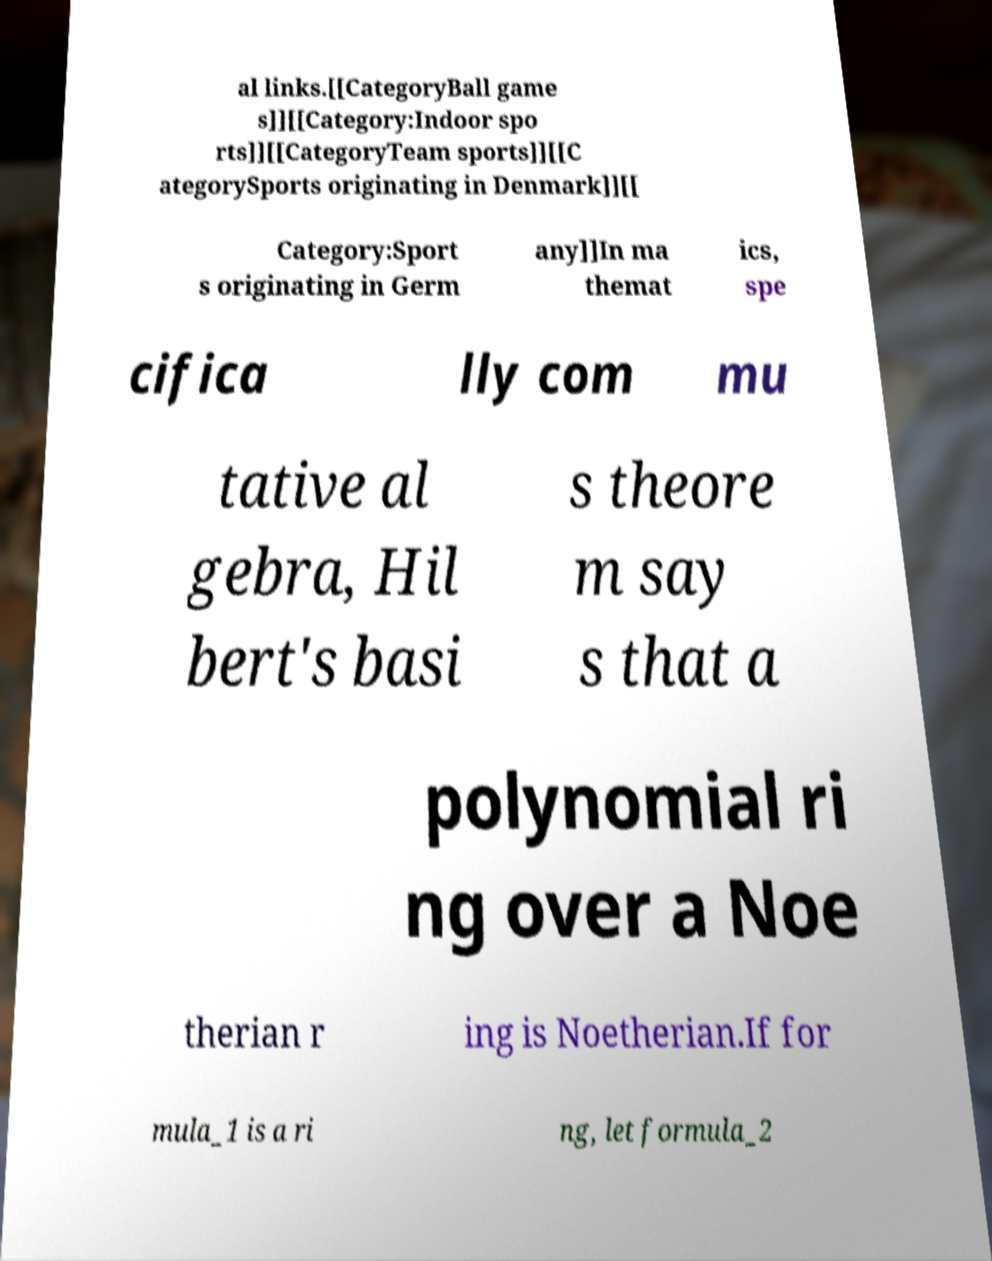There's text embedded in this image that I need extracted. Can you transcribe it verbatim? al links.[[CategoryBall game s]][[Category:Indoor spo rts]][[CategoryTeam sports]][[C ategorySports originating in Denmark]][[ Category:Sport s originating in Germ any]]In ma themat ics, spe cifica lly com mu tative al gebra, Hil bert's basi s theore m say s that a polynomial ri ng over a Noe therian r ing is Noetherian.If for mula_1 is a ri ng, let formula_2 